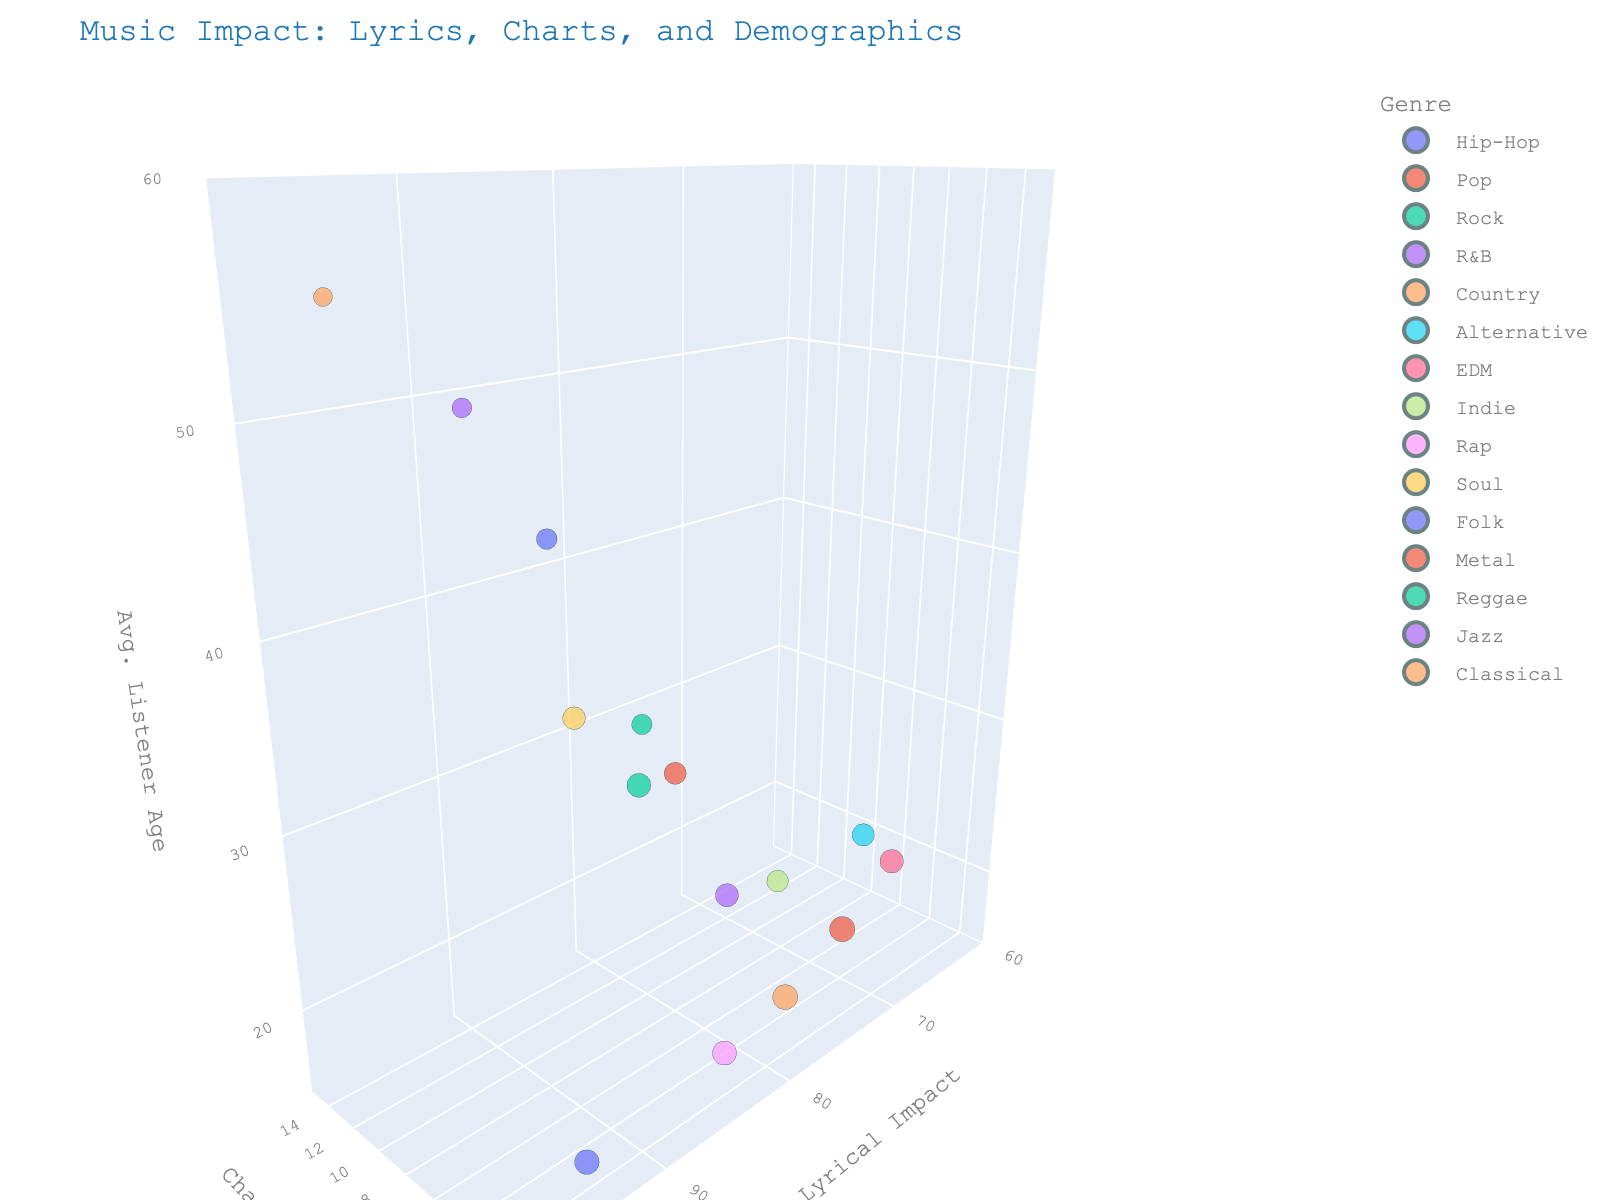What is the title of the chart? The title is prominently displayed at the top of the chart. It summarizes what the chart is about.
Answer: Music Impact: Lyrics, Charts, and Demographics How does the chart position of "Symphony No. 5" compare to "What a Wonderful World"? "Symphony No. 5" is plotted at a chart position of 15 while "What a Wonderful World" is at 12. You can interpret this by checking the y-axis values.
Answer: Symphony No. 5 is higher (worse) Which genre has the highest average listener age and what is its song? By looking at the z-axis, the highest point corresponds to the Classical genre with "Symphony No. 5".
Answer: Classical with Symphony No. 5 Between Rap and Pop genres, which has a higher lyrical impact? Look at the x-axis values: Rap's "God's Plan" at 85 and Pop's "Shape of You" at 75.
Answer: Rap What is the range of chart positions represented in the chart? Check the y-axis labels from the lowest to the highest value plotted. The y-axis ranges from 1 to 15 inclusive.
Answer: 1 to 15 Which genre has a song with the lowest popularity and what is the popularity score? The size of the bubbles represents popularity. The smallest bubble is for Classical's "Symphony No. 5" with a popularity of 50.
Answer: Classical, 50 How many genres have songs charting at the number 1 position? Identify the bubbles at the chart position 1 (lowest y value) and count the different genres. There are five: Hip-Hop, Pop, R&B, Country, Rap.
Answer: Five What is the difference in listener age between "Bohemian Rhapsody" and "Sweater Weather"? By comparing z-axis values: "Bohemian Rhapsody" at 35 and "Sweater Weather" at 23. The difference is 35 - 23.
Answer: 12 years Which song has the highest lyrical impact and what genre does it belong to? The highest x-axis value is 95, shared by Hip-Hop's "Lose Yourself," Soul's "Respect," and Classical's "Symphony No. 5."
Answer: "Lose Yourself" (Hip-Hop), "Respect" (Soul), "Symphony No. 5" (Classical) What is the average listener age of songs with a chart position of 1? Locate all bubbles at chart position 1 (y-axis value) and compute their average listener age (z-axis values): "Lose Yourself" (18), "Shape of You" (22), "All of Me" (28), "Old Town Road" (20), "God’s Plan" (19). Average: (18 + 22 + 28 + 20 + 19)/5 = 21.4
Answer: 21.4 years 